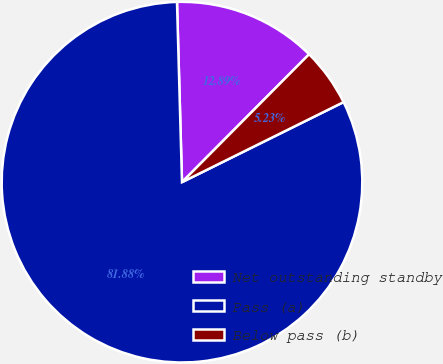Convert chart to OTSL. <chart><loc_0><loc_0><loc_500><loc_500><pie_chart><fcel>Net outstanding standby<fcel>Pass (a)<fcel>Below pass (b)<nl><fcel>12.89%<fcel>81.88%<fcel>5.23%<nl></chart> 